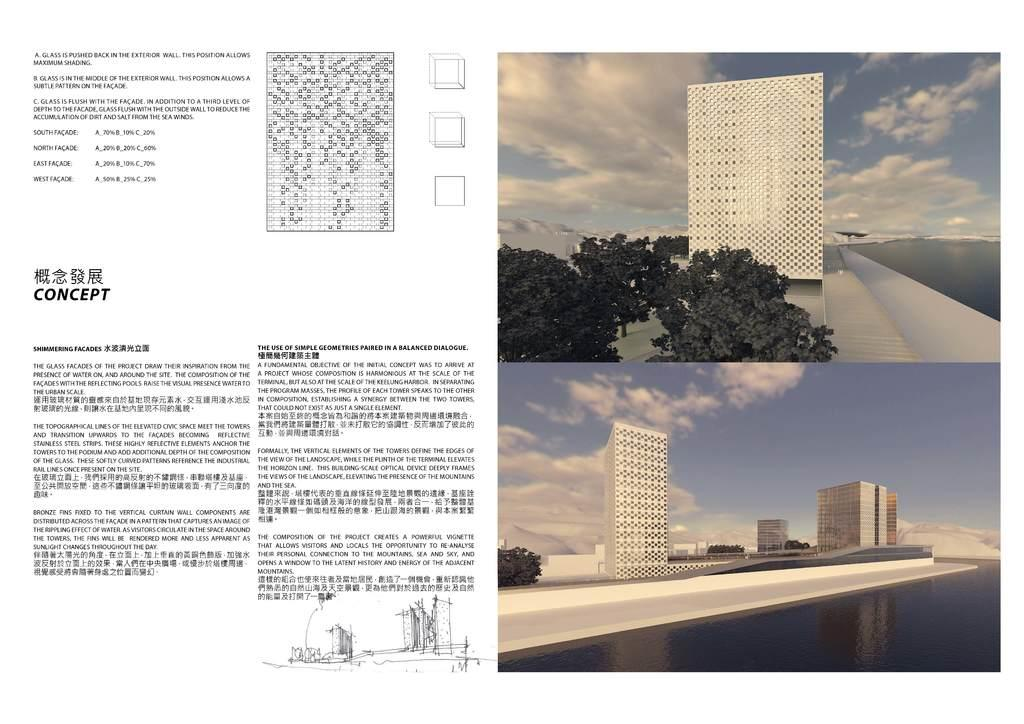What type of artwork is the image? The image is a collage. What structures can be seen in the collage? There are buildings in the image. What type of natural elements are present in the collage? There are trees and water visible in the image. What part of the natural environment is visible in the image? The sky is visible in the image, and there are clouds in the sky. Is there any text present in the image? Yes, there is text present in the image. What type of gold star can be seen on top of the tallest building in the image? There is no gold star present on top of any building in the image. 